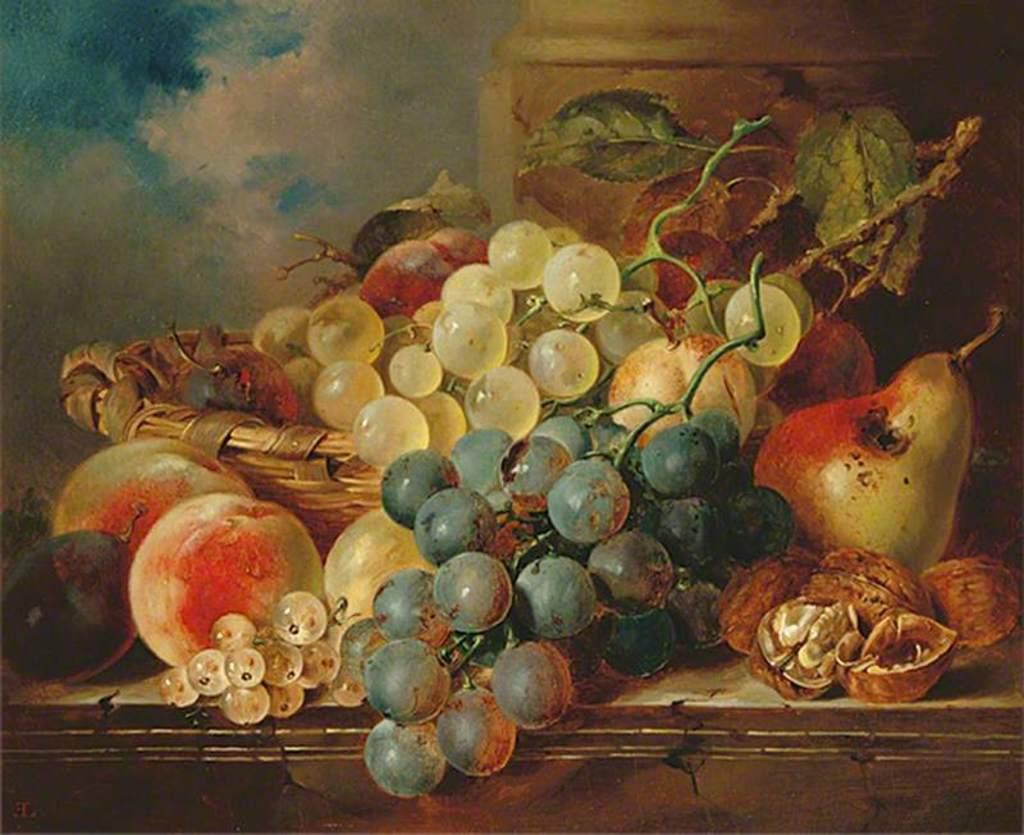In one or two sentences, can you explain what this image depicts? This is a painting and in this painting we can see a basket, fruits, leaves and in the background we can see the sky with clouds. 